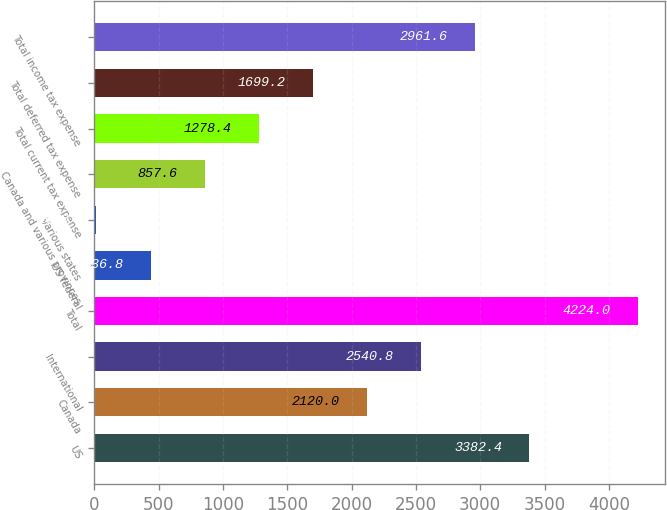Convert chart to OTSL. <chart><loc_0><loc_0><loc_500><loc_500><bar_chart><fcel>US<fcel>Canada<fcel>International<fcel>Total<fcel>US federal<fcel>Various states<fcel>Canada and various provinces<fcel>Total current tax expense<fcel>Total deferred tax expense<fcel>Total income tax expense<nl><fcel>3382.4<fcel>2120<fcel>2540.8<fcel>4224<fcel>436.8<fcel>16<fcel>857.6<fcel>1278.4<fcel>1699.2<fcel>2961.6<nl></chart> 